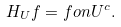<formula> <loc_0><loc_0><loc_500><loc_500>H _ { U } f = f o n U ^ { c } .</formula> 